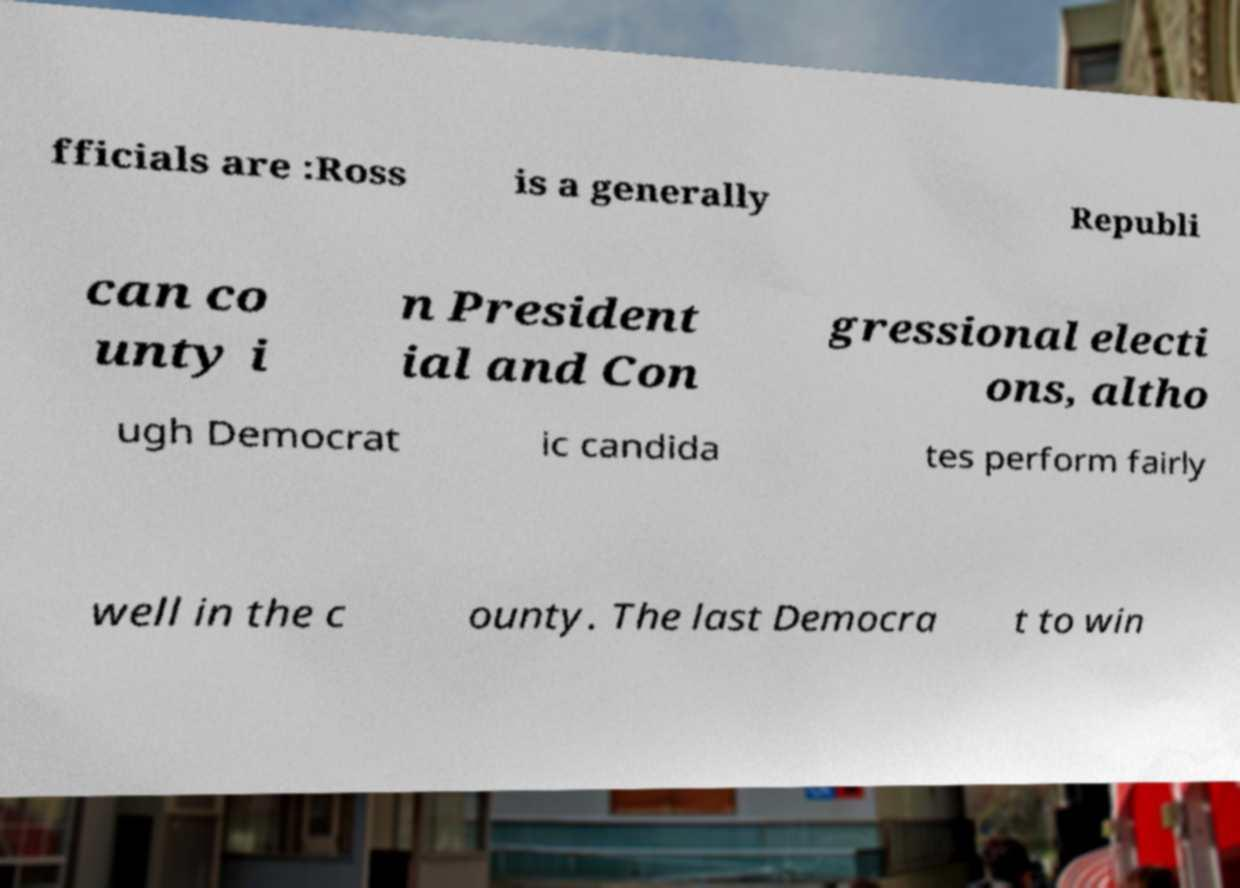There's text embedded in this image that I need extracted. Can you transcribe it verbatim? fficials are :Ross is a generally Republi can co unty i n President ial and Con gressional electi ons, altho ugh Democrat ic candida tes perform fairly well in the c ounty. The last Democra t to win 